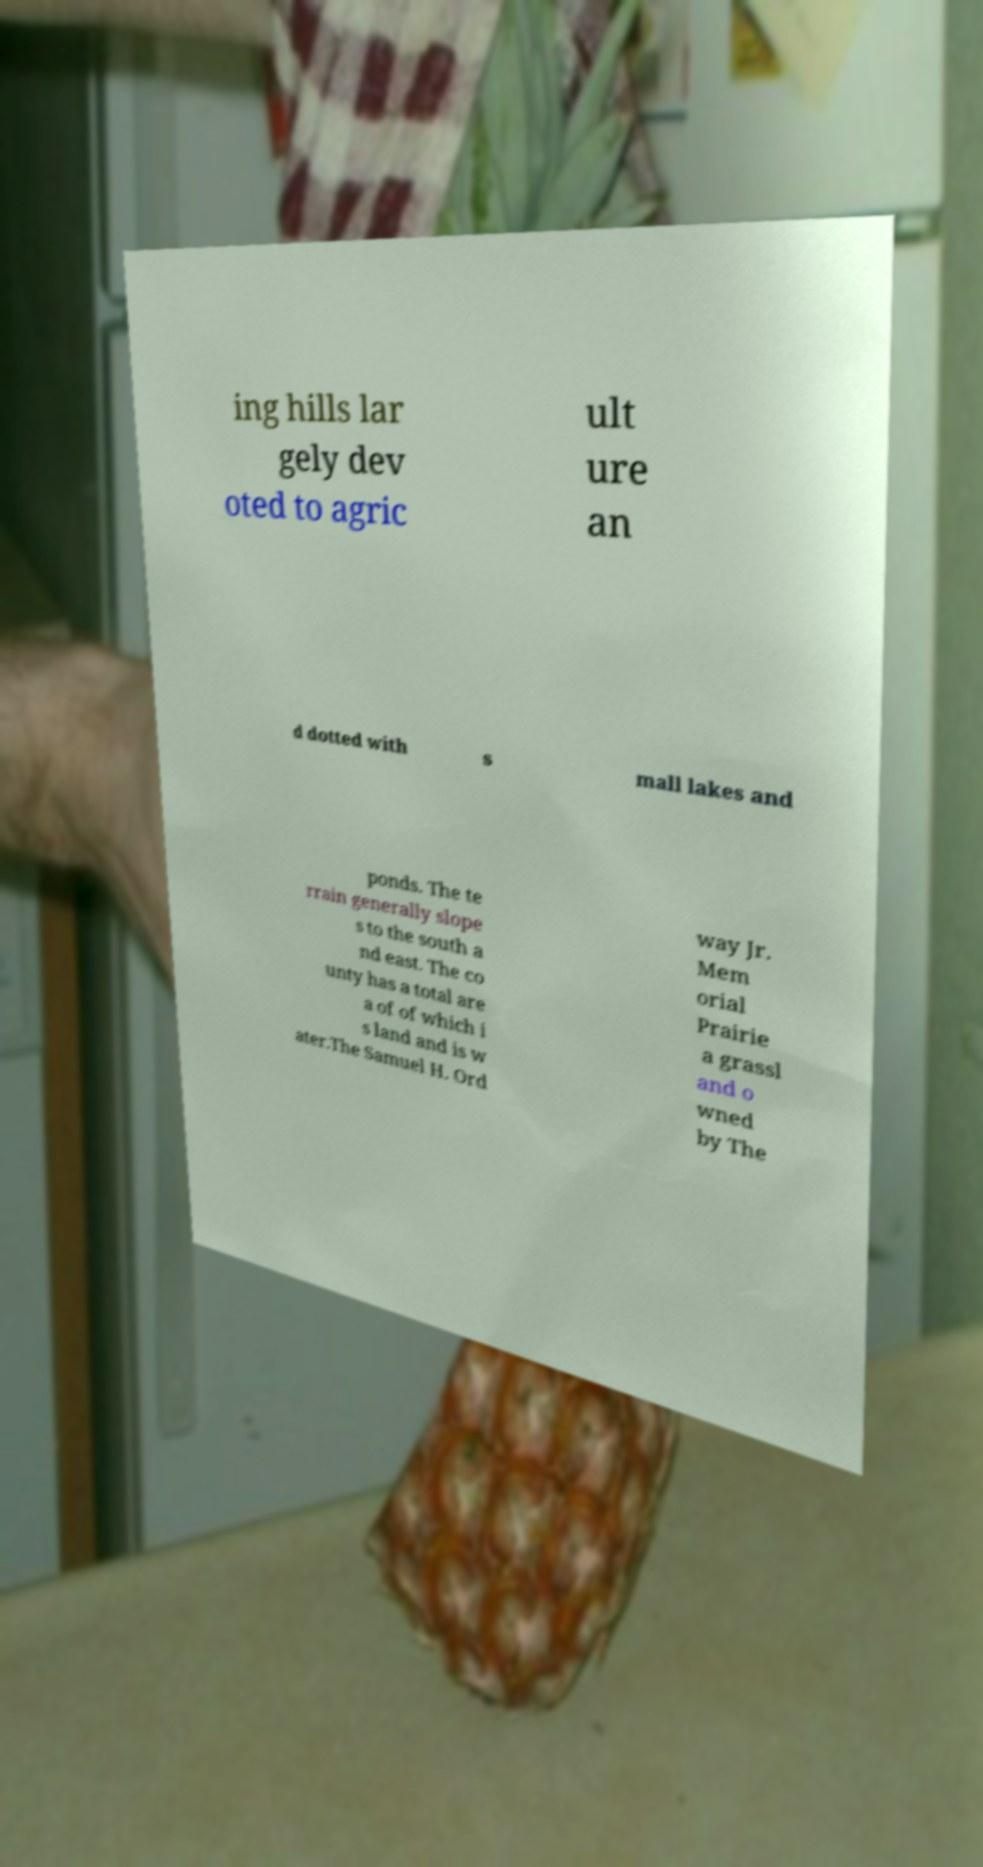Could you extract and type out the text from this image? ing hills lar gely dev oted to agric ult ure an d dotted with s mall lakes and ponds. The te rrain generally slope s to the south a nd east. The co unty has a total are a of of which i s land and is w ater.The Samuel H. Ord way Jr. Mem orial Prairie a grassl and o wned by The 